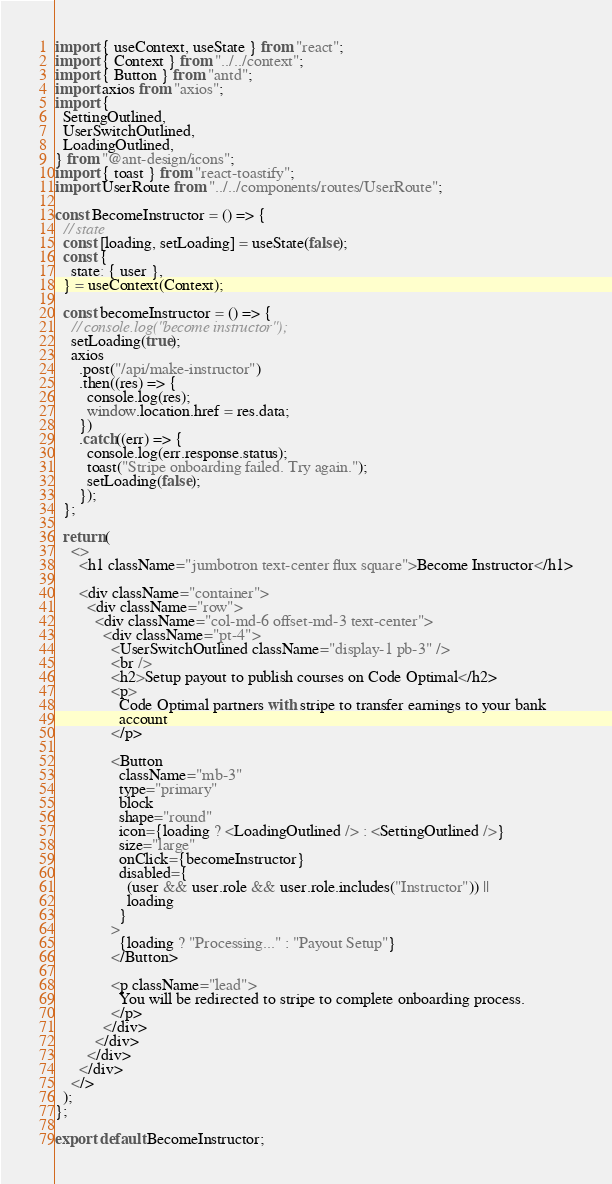<code> <loc_0><loc_0><loc_500><loc_500><_JavaScript_>import { useContext, useState } from "react";
import { Context } from "../../context";
import { Button } from "antd";
import axios from "axios";
import {
  SettingOutlined,
  UserSwitchOutlined,
  LoadingOutlined,
} from "@ant-design/icons";
import { toast } from "react-toastify";
import UserRoute from "../../components/routes/UserRoute";

const BecomeInstructor = () => {
  // state
  const [loading, setLoading] = useState(false);
  const {
    state: { user },
  } = useContext(Context);

  const becomeInstructor = () => {
    // console.log("become instructor");
    setLoading(true);
    axios
      .post("/api/make-instructor")
      .then((res) => {
        console.log(res);
        window.location.href = res.data;
      })
      .catch((err) => {
        console.log(err.response.status);
        toast("Stripe onboarding failed. Try again.");
        setLoading(false);
      });
  };

  return (
    <>
      <h1 className="jumbotron text-center flux square">Become Instructor</h1>

      <div className="container">
        <div className="row">
          <div className="col-md-6 offset-md-3 text-center">
            <div className="pt-4">
              <UserSwitchOutlined className="display-1 pb-3" />
              <br />
              <h2>Setup payout to publish courses on Code Optimal</h2>
              <p>
                Code Optimal partners with stripe to transfer earnings to your bank
                account
              </p>

              <Button
                className="mb-3"
                type="primary"
                block
                shape="round"
                icon={loading ? <LoadingOutlined /> : <SettingOutlined />}
                size="large"
                onClick={becomeInstructor}
                disabled={
                  (user && user.role && user.role.includes("Instructor")) ||
                  loading
                }
              >
                {loading ? "Processing..." : "Payout Setup"}
              </Button>

              <p className="lead">
                You will be redirected to stripe to complete onboarding process.
              </p>
            </div>
          </div>
        </div>
      </div>
    </>
  );
};

export default BecomeInstructor;
</code> 